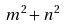Convert formula to latex. <formula><loc_0><loc_0><loc_500><loc_500>m ^ { 2 } + n ^ { 2 }</formula> 